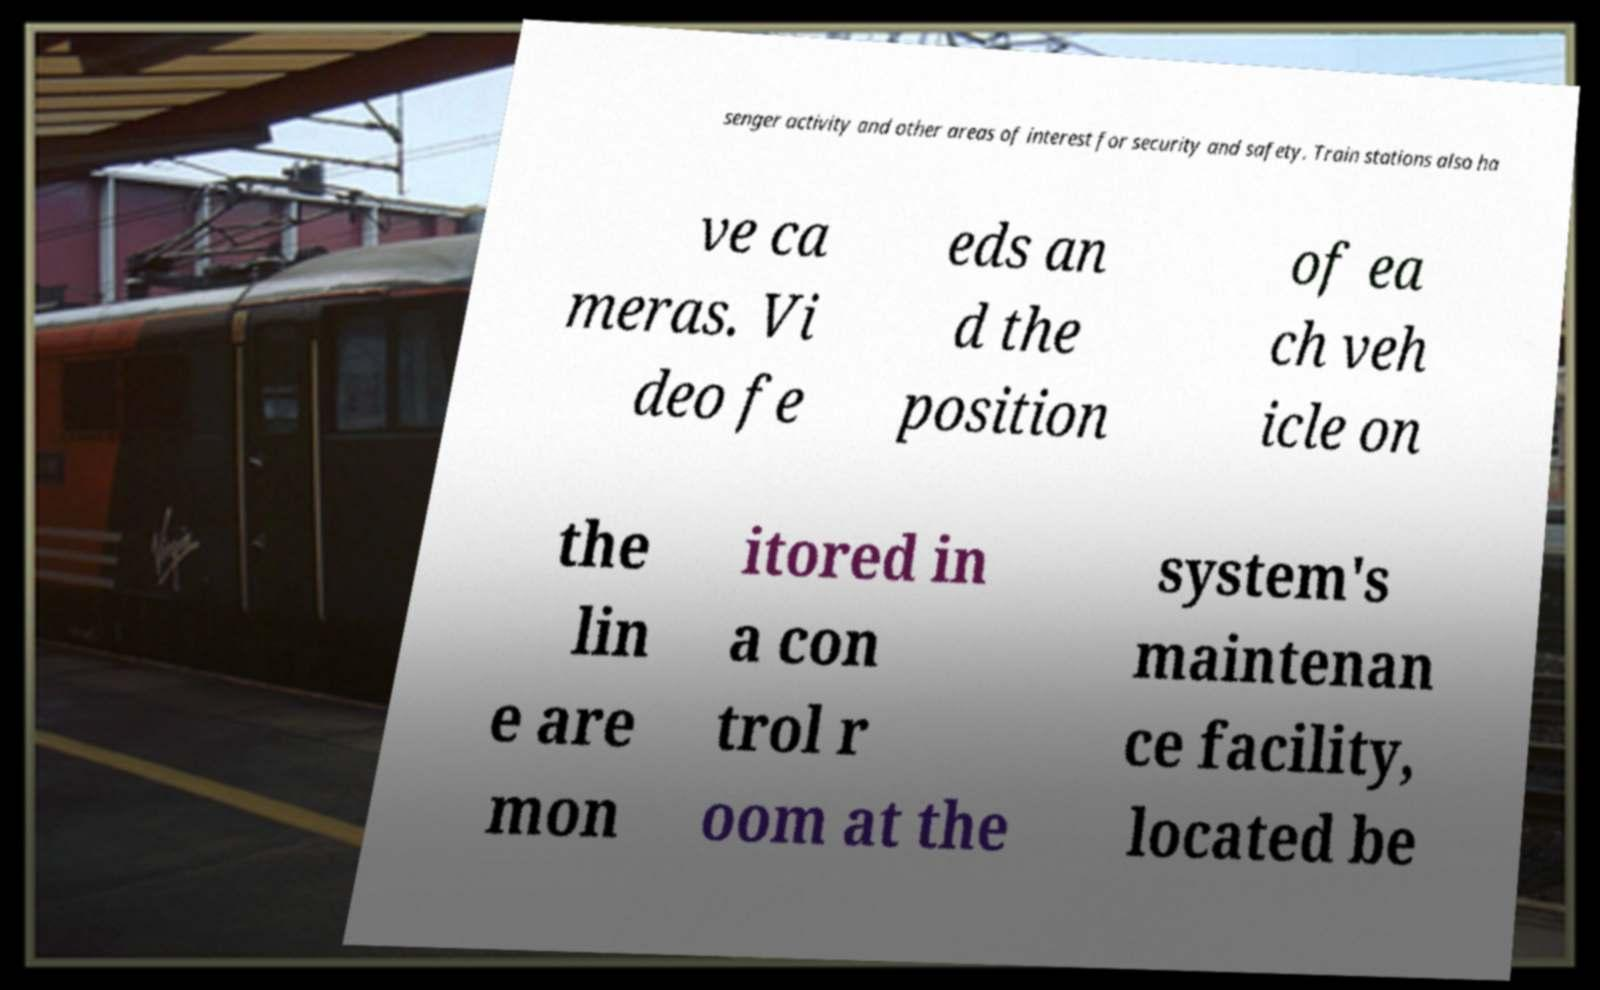Can you accurately transcribe the text from the provided image for me? senger activity and other areas of interest for security and safety. Train stations also ha ve ca meras. Vi deo fe eds an d the position of ea ch veh icle on the lin e are mon itored in a con trol r oom at the system's maintenan ce facility, located be 